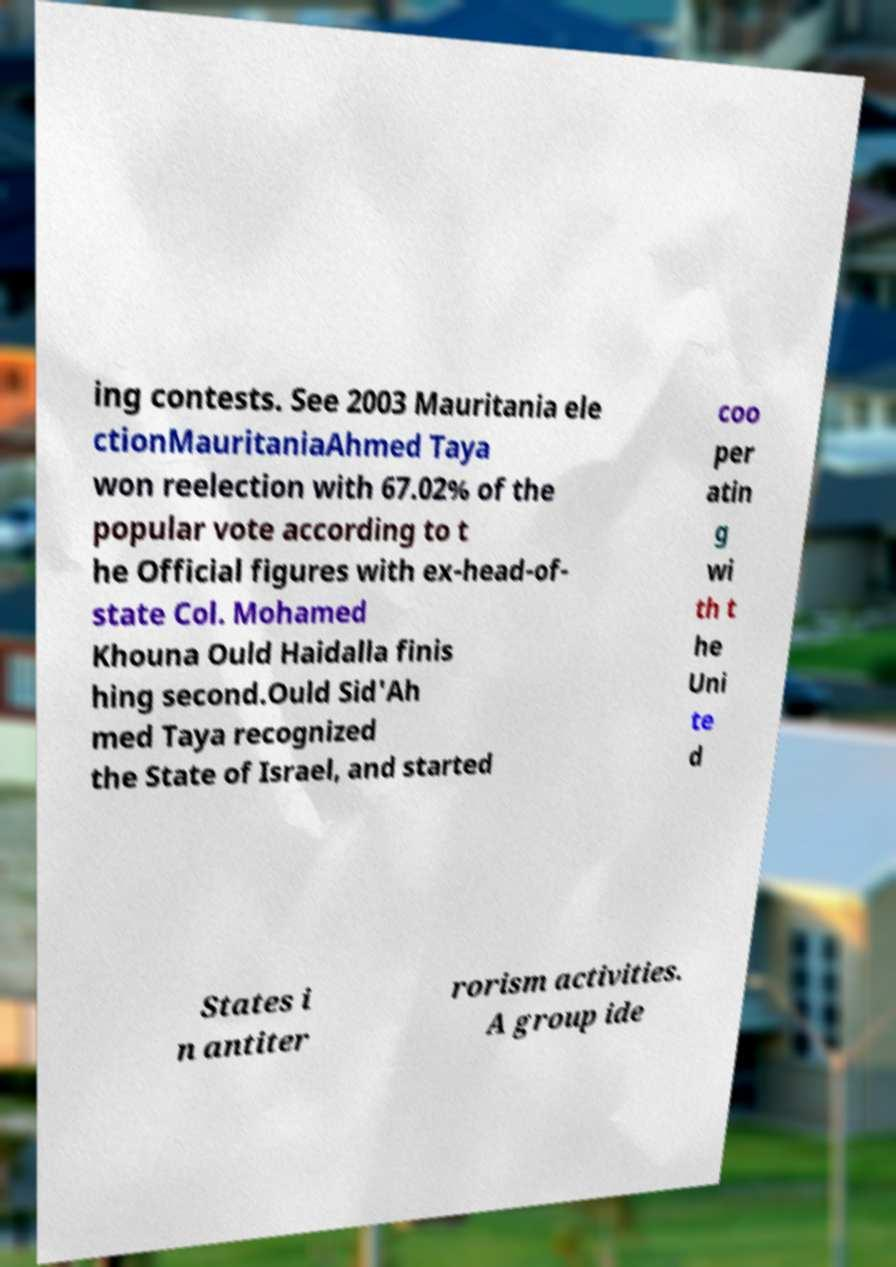Please identify and transcribe the text found in this image. ing contests. See 2003 Mauritania ele ctionMauritaniaAhmed Taya won reelection with 67.02% of the popular vote according to t he Official figures with ex-head-of- state Col. Mohamed Khouna Ould Haidalla finis hing second.Ould Sid'Ah med Taya recognized the State of Israel, and started coo per atin g wi th t he Uni te d States i n antiter rorism activities. A group ide 